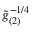<formula> <loc_0><loc_0><loc_500><loc_500>\tilde { g } _ { ( 2 ) } ^ { - 1 / 4 }</formula> 